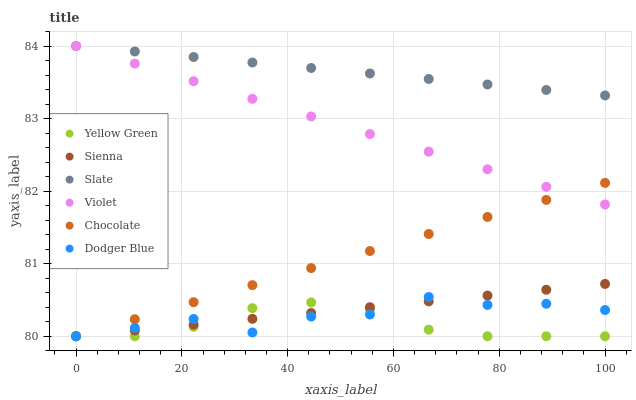Does Yellow Green have the minimum area under the curve?
Answer yes or no. Yes. Does Slate have the maximum area under the curve?
Answer yes or no. Yes. Does Chocolate have the minimum area under the curve?
Answer yes or no. No. Does Chocolate have the maximum area under the curve?
Answer yes or no. No. Is Slate the smoothest?
Answer yes or no. Yes. Is Dodger Blue the roughest?
Answer yes or no. Yes. Is Chocolate the smoothest?
Answer yes or no. No. Is Chocolate the roughest?
Answer yes or no. No. Does Yellow Green have the lowest value?
Answer yes or no. Yes. Does Slate have the lowest value?
Answer yes or no. No. Does Violet have the highest value?
Answer yes or no. Yes. Does Chocolate have the highest value?
Answer yes or no. No. Is Yellow Green less than Slate?
Answer yes or no. Yes. Is Slate greater than Yellow Green?
Answer yes or no. Yes. Does Chocolate intersect Sienna?
Answer yes or no. Yes. Is Chocolate less than Sienna?
Answer yes or no. No. Is Chocolate greater than Sienna?
Answer yes or no. No. Does Yellow Green intersect Slate?
Answer yes or no. No. 